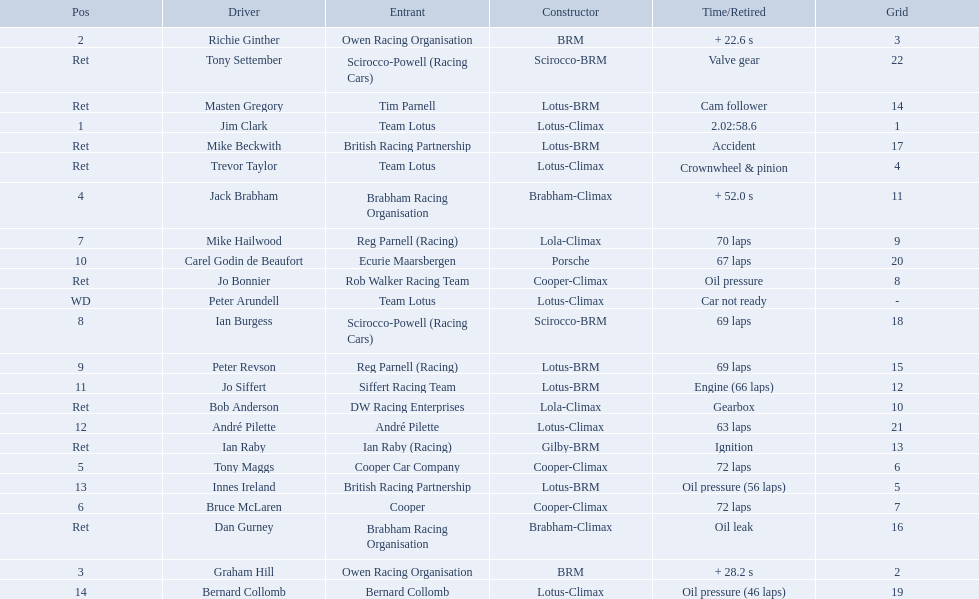Who were the two that that a similar problem? Innes Ireland. What was their common problem? Oil pressure. What are the listed driver names? Jim Clark, Richie Ginther, Graham Hill, Jack Brabham, Tony Maggs, Bruce McLaren, Mike Hailwood, Ian Burgess, Peter Revson, Carel Godin de Beaufort, Jo Siffert, André Pilette, Innes Ireland, Bernard Collomb, Ian Raby, Dan Gurney, Mike Beckwith, Masten Gregory, Trevor Taylor, Jo Bonnier, Tony Settember, Bob Anderson, Peter Arundell. Which are tony maggs and jo siffert? Tony Maggs, Jo Siffert. What are their corresponding finishing places? 5, 11. Whose is better? Tony Maggs. 